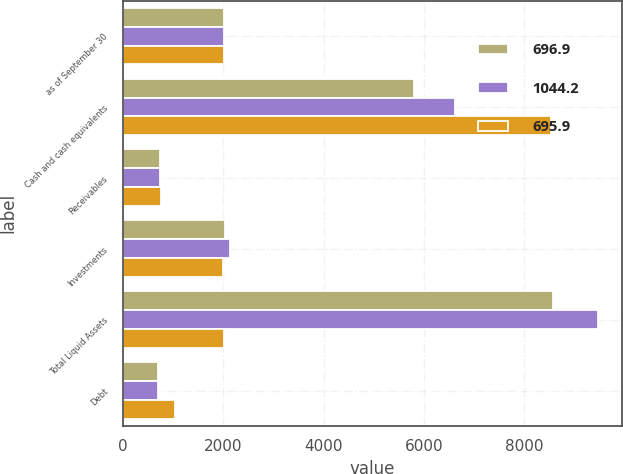Convert chart to OTSL. <chart><loc_0><loc_0><loc_500><loc_500><stacked_bar_chart><ecel><fcel>as of September 30<fcel>Cash and cash equivalents<fcel>Receivables<fcel>Investments<fcel>Total Liquid Assets<fcel>Debt<nl><fcel>696.9<fcel>2019<fcel>5803.4<fcel>740<fcel>2029.4<fcel>8572.8<fcel>696.9<nl><fcel>1044.2<fcel>2018<fcel>6610.8<fcel>733.7<fcel>2130.6<fcel>9475.1<fcel>695.9<nl><fcel>695.9<fcel>2017<fcel>8523.3<fcel>767.8<fcel>1995.2<fcel>2018<fcel>1044.2<nl></chart> 